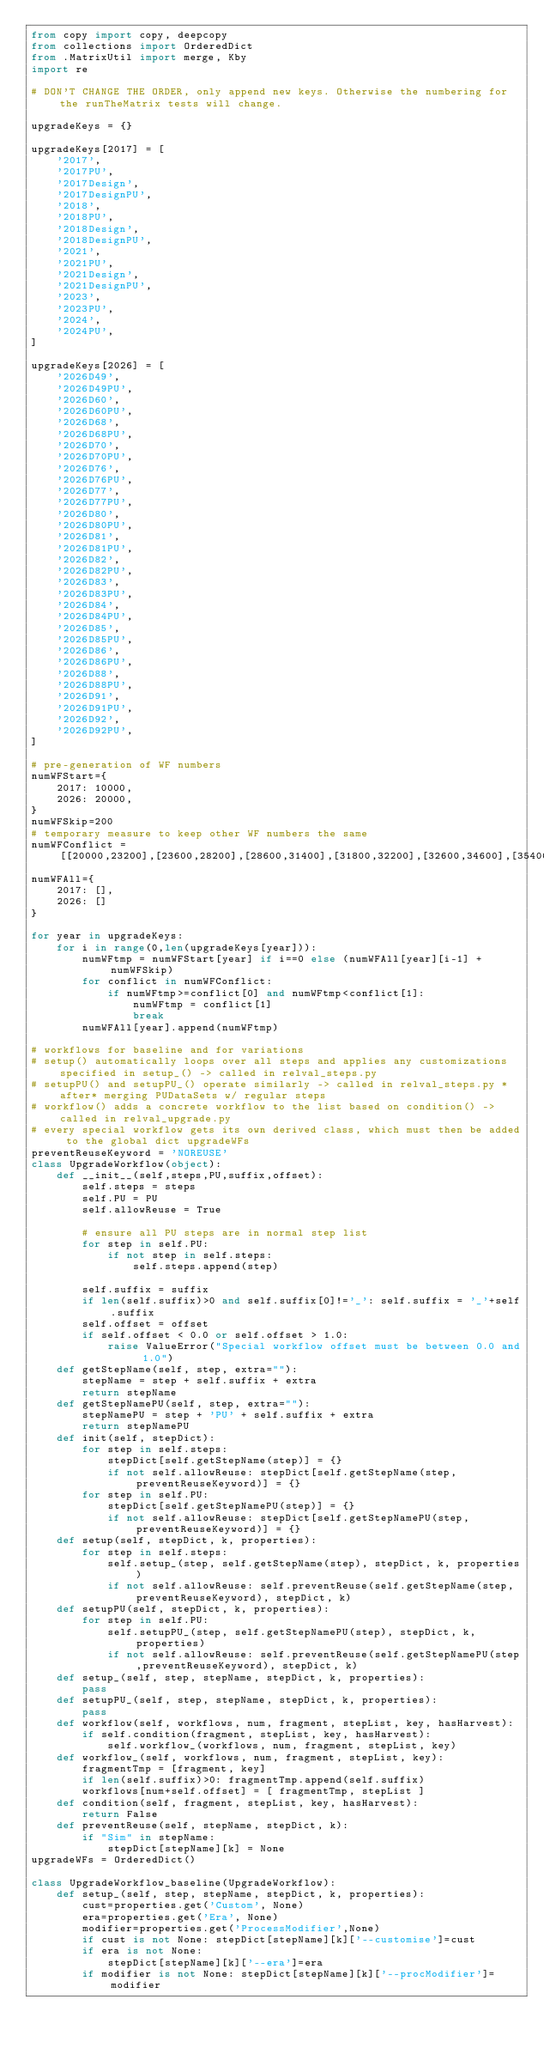<code> <loc_0><loc_0><loc_500><loc_500><_Python_>from copy import copy, deepcopy
from collections import OrderedDict
from .MatrixUtil import merge, Kby
import re

# DON'T CHANGE THE ORDER, only append new keys. Otherwise the numbering for the runTheMatrix tests will change.

upgradeKeys = {}

upgradeKeys[2017] = [
    '2017',
    '2017PU',
    '2017Design',
    '2017DesignPU',
    '2018',
    '2018PU',
    '2018Design',
    '2018DesignPU',
    '2021',
    '2021PU',
    '2021Design',
    '2021DesignPU',
    '2023',
    '2023PU',
    '2024',
    '2024PU',
] 

upgradeKeys[2026] = [
    '2026D49',
    '2026D49PU',
    '2026D60',
    '2026D60PU',
    '2026D68',
    '2026D68PU',
    '2026D70',
    '2026D70PU',
    '2026D76',
    '2026D76PU',
    '2026D77',
    '2026D77PU',
    '2026D80',
    '2026D80PU',
    '2026D81',
    '2026D81PU',
    '2026D82',
    '2026D82PU',
    '2026D83',
    '2026D83PU',
    '2026D84',
    '2026D84PU',
    '2026D85',
    '2026D85PU',
    '2026D86',
    '2026D86PU',
    '2026D88',
    '2026D88PU',
    '2026D91',
    '2026D91PU',
    '2026D92',
    '2026D92PU',
]

# pre-generation of WF numbers
numWFStart={
    2017: 10000,
    2026: 20000,
}
numWFSkip=200
# temporary measure to keep other WF numbers the same
numWFConflict = [[20000,23200],[23600,28200],[28600,31400],[31800,32200],[32600,34600],[35400,36200],[39000,39400],[39800,40600],[50000,51000]]
numWFAll={
    2017: [],
    2026: []
}

for year in upgradeKeys:
    for i in range(0,len(upgradeKeys[year])):
        numWFtmp = numWFStart[year] if i==0 else (numWFAll[year][i-1] + numWFSkip)
        for conflict in numWFConflict:
            if numWFtmp>=conflict[0] and numWFtmp<conflict[1]:
                numWFtmp = conflict[1]
                break
        numWFAll[year].append(numWFtmp)

# workflows for baseline and for variations
# setup() automatically loops over all steps and applies any customizations specified in setup_() -> called in relval_steps.py
# setupPU() and setupPU_() operate similarly -> called in relval_steps.py *after* merging PUDataSets w/ regular steps
# workflow() adds a concrete workflow to the list based on condition() -> called in relval_upgrade.py
# every special workflow gets its own derived class, which must then be added to the global dict upgradeWFs
preventReuseKeyword = 'NOREUSE'
class UpgradeWorkflow(object):
    def __init__(self,steps,PU,suffix,offset):
        self.steps = steps
        self.PU = PU
        self.allowReuse = True

        # ensure all PU steps are in normal step list
        for step in self.PU:
            if not step in self.steps:
                self.steps.append(step)

        self.suffix = suffix
        if len(self.suffix)>0 and self.suffix[0]!='_': self.suffix = '_'+self.suffix
        self.offset = offset
        if self.offset < 0.0 or self.offset > 1.0:
            raise ValueError("Special workflow offset must be between 0.0 and 1.0")
    def getStepName(self, step, extra=""):
        stepName = step + self.suffix + extra
        return stepName
    def getStepNamePU(self, step, extra=""):
        stepNamePU = step + 'PU' + self.suffix + extra
        return stepNamePU
    def init(self, stepDict):
        for step in self.steps:
            stepDict[self.getStepName(step)] = {}
            if not self.allowReuse: stepDict[self.getStepName(step,preventReuseKeyword)] = {}
        for step in self.PU:
            stepDict[self.getStepNamePU(step)] = {}
            if not self.allowReuse: stepDict[self.getStepNamePU(step,preventReuseKeyword)] = {}
    def setup(self, stepDict, k, properties):
        for step in self.steps:
            self.setup_(step, self.getStepName(step), stepDict, k, properties)
            if not self.allowReuse: self.preventReuse(self.getStepName(step,preventReuseKeyword), stepDict, k)
    def setupPU(self, stepDict, k, properties):
        for step in self.PU:
            self.setupPU_(step, self.getStepNamePU(step), stepDict, k, properties)
            if not self.allowReuse: self.preventReuse(self.getStepNamePU(step,preventReuseKeyword), stepDict, k)
    def setup_(self, step, stepName, stepDict, k, properties):
        pass
    def setupPU_(self, step, stepName, stepDict, k, properties):
        pass
    def workflow(self, workflows, num, fragment, stepList, key, hasHarvest):
        if self.condition(fragment, stepList, key, hasHarvest):
            self.workflow_(workflows, num, fragment, stepList, key)
    def workflow_(self, workflows, num, fragment, stepList, key):
        fragmentTmp = [fragment, key]
        if len(self.suffix)>0: fragmentTmp.append(self.suffix)
        workflows[num+self.offset] = [ fragmentTmp, stepList ]
    def condition(self, fragment, stepList, key, hasHarvest):
        return False
    def preventReuse(self, stepName, stepDict, k):
        if "Sim" in stepName:
            stepDict[stepName][k] = None
upgradeWFs = OrderedDict()

class UpgradeWorkflow_baseline(UpgradeWorkflow):
    def setup_(self, step, stepName, stepDict, k, properties):
        cust=properties.get('Custom', None)
        era=properties.get('Era', None)
        modifier=properties.get('ProcessModifier',None)
        if cust is not None: stepDict[stepName][k]['--customise']=cust
        if era is not None:
            stepDict[stepName][k]['--era']=era
        if modifier is not None: stepDict[stepName][k]['--procModifier']=modifier</code> 